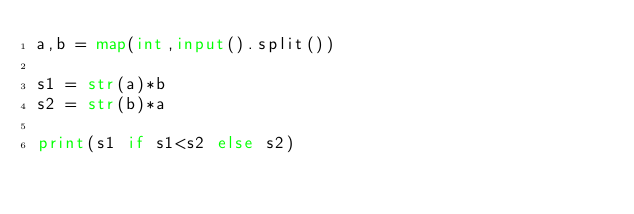Convert code to text. <code><loc_0><loc_0><loc_500><loc_500><_Python_>a,b = map(int,input().split())

s1 = str(a)*b
s2 = str(b)*a

print(s1 if s1<s2 else s2)
</code> 